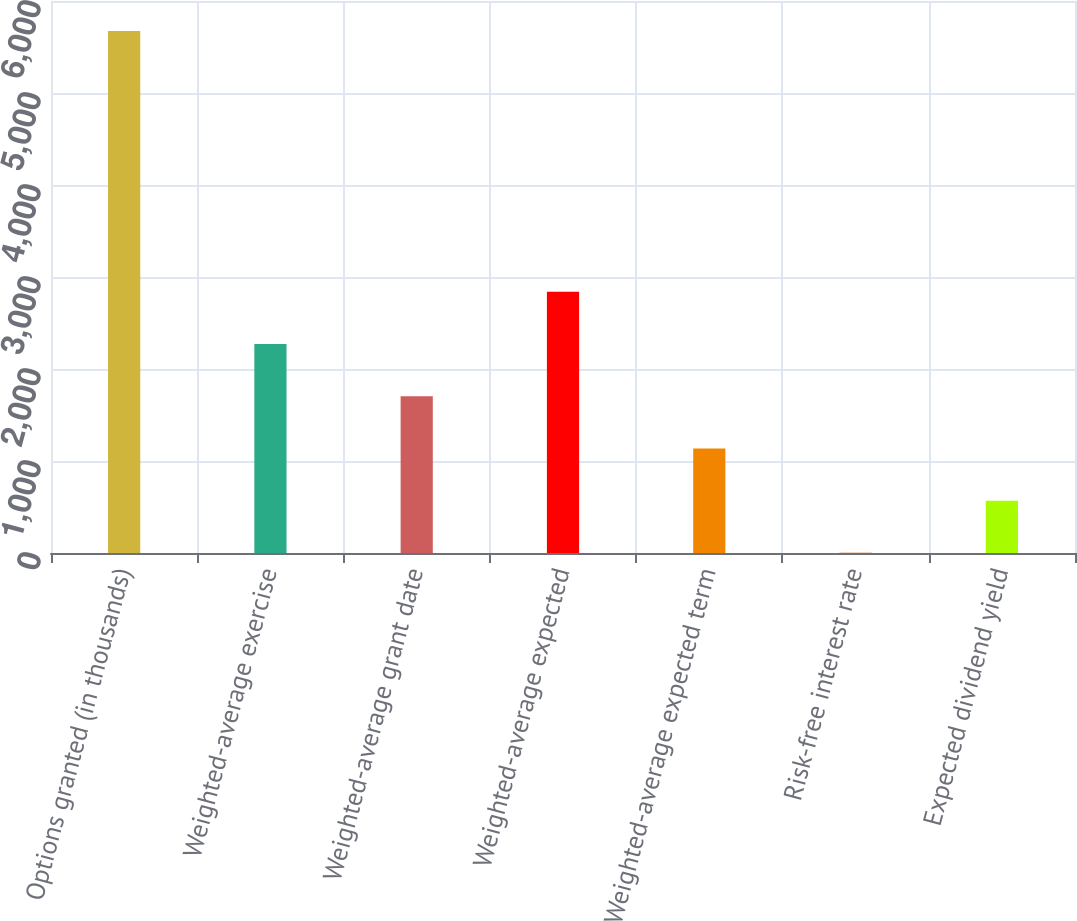Convert chart to OTSL. <chart><loc_0><loc_0><loc_500><loc_500><bar_chart><fcel>Options granted (in thousands)<fcel>Weighted-average exercise<fcel>Weighted-average grant date<fcel>Weighted-average expected<fcel>Weighted-average expected term<fcel>Risk-free interest rate<fcel>Expected dividend yield<nl><fcel>5675<fcel>2271.02<fcel>1703.69<fcel>2838.35<fcel>1136.36<fcel>1.7<fcel>569.03<nl></chart> 